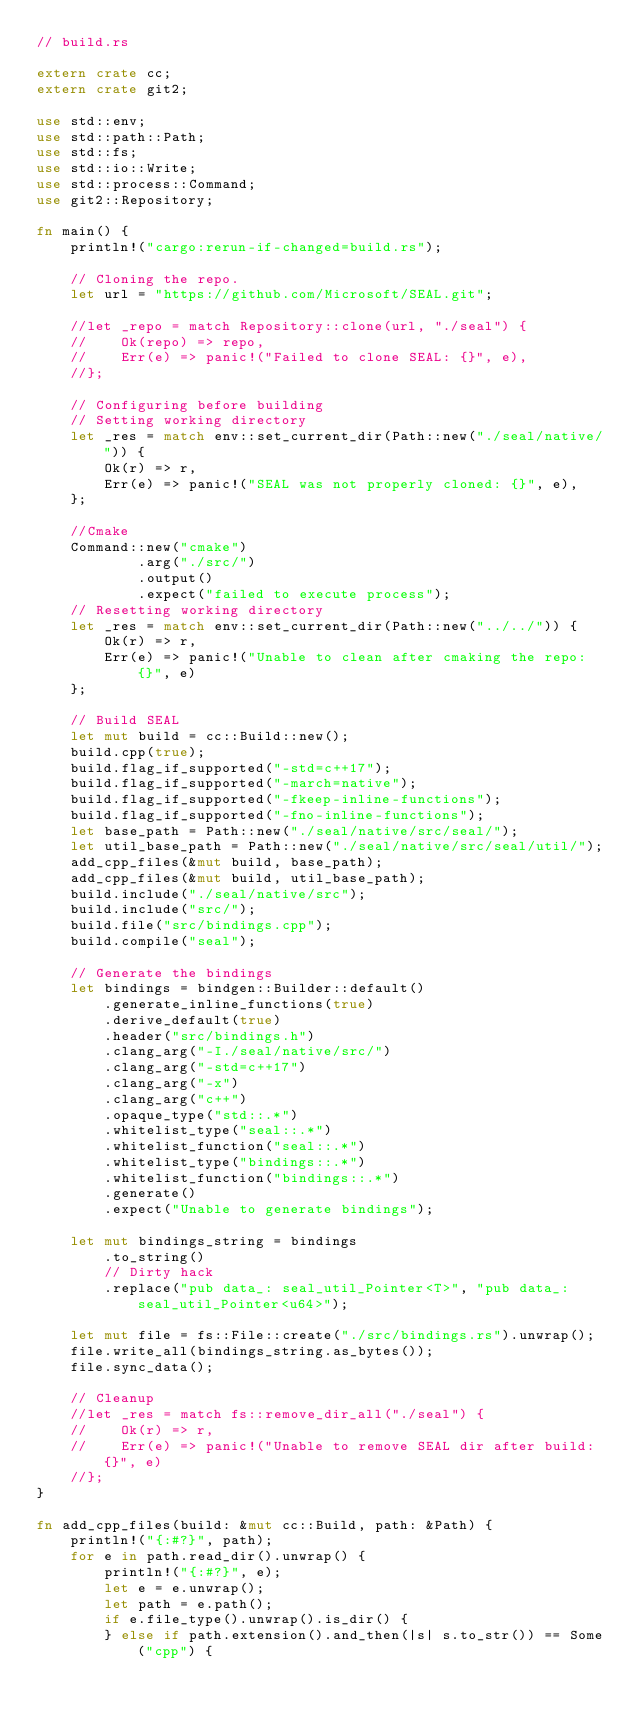<code> <loc_0><loc_0><loc_500><loc_500><_Rust_>// build.rs

extern crate cc;
extern crate git2;

use std::env;
use std::path::Path;
use std::fs;
use std::io::Write;
use std::process::Command;
use git2::Repository;

fn main() {
    println!("cargo:rerun-if-changed=build.rs");

    // Cloning the repo.
    let url = "https://github.com/Microsoft/SEAL.git";

    //let _repo = match Repository::clone(url, "./seal") {
    //    Ok(repo) => repo,
    //    Err(e) => panic!("Failed to clone SEAL: {}", e),
    //};

    // Configuring before building
    // Setting working directory
    let _res = match env::set_current_dir(Path::new("./seal/native/")) {
        Ok(r) => r,
        Err(e) => panic!("SEAL was not properly cloned: {}", e),
    };

    //Cmake
    Command::new("cmake")
            .arg("./src/")
            .output()
            .expect("failed to execute process");
    // Resetting working directory
    let _res = match env::set_current_dir(Path::new("../../")) {
        Ok(r) => r,
        Err(e) => panic!("Unable to clean after cmaking the repo: {}", e)
    };

    // Build SEAL
    let mut build = cc::Build::new();
    build.cpp(true);
    build.flag_if_supported("-std=c++17");
    build.flag_if_supported("-march=native");
    build.flag_if_supported("-fkeep-inline-functions");
    build.flag_if_supported("-fno-inline-functions");
    let base_path = Path::new("./seal/native/src/seal/");
    let util_base_path = Path::new("./seal/native/src/seal/util/");
    add_cpp_files(&mut build, base_path);
    add_cpp_files(&mut build, util_base_path);
    build.include("./seal/native/src");
    build.include("src/");
    build.file("src/bindings.cpp");
    build.compile("seal");

    // Generate the bindings
    let bindings = bindgen::Builder::default()
        .generate_inline_functions(true)
        .derive_default(true)
        .header("src/bindings.h")
        .clang_arg("-I./seal/native/src/")
        .clang_arg("-std=c++17")
        .clang_arg("-x")
        .clang_arg("c++")
        .opaque_type("std::.*")
        .whitelist_type("seal::.*")
        .whitelist_function("seal::.*")
        .whitelist_type("bindings::.*")
        .whitelist_function("bindings::.*")
        .generate()
        .expect("Unable to generate bindings");

    let mut bindings_string = bindings
        .to_string()
        // Dirty hack
        .replace("pub data_: seal_util_Pointer<T>", "pub data_: seal_util_Pointer<u64>");

    let mut file = fs::File::create("./src/bindings.rs").unwrap();
    file.write_all(bindings_string.as_bytes());
    file.sync_data();

    // Cleanup
    //let _res = match fs::remove_dir_all("./seal") {
    //    Ok(r) => r,
    //    Err(e) => panic!("Unable to remove SEAL dir after build: {}", e)
    //};
}

fn add_cpp_files(build: &mut cc::Build, path: &Path) {
    println!("{:#?}", path);
    for e in path.read_dir().unwrap() {
        println!("{:#?}", e);
        let e = e.unwrap();
        let path = e.path();
        if e.file_type().unwrap().is_dir() {
        } else if path.extension().and_then(|s| s.to_str()) == Some("cpp") {</code> 